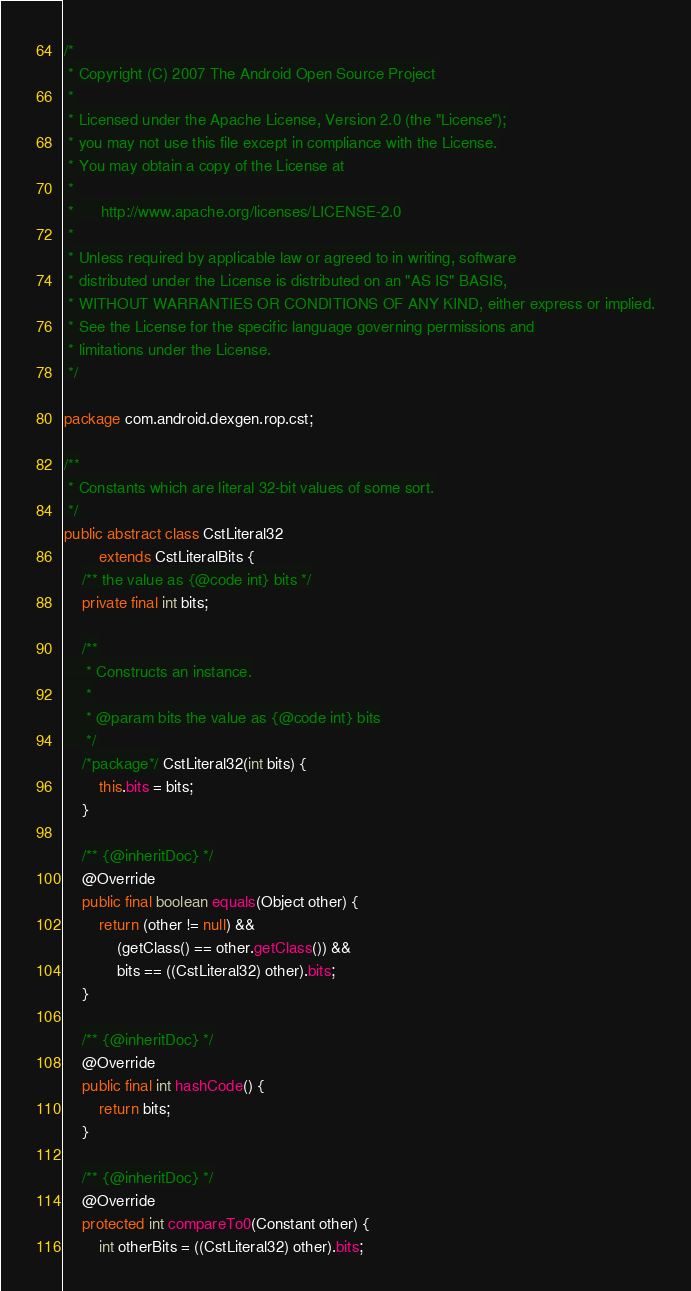Convert code to text. <code><loc_0><loc_0><loc_500><loc_500><_Java_>/*
 * Copyright (C) 2007 The Android Open Source Project
 *
 * Licensed under the Apache License, Version 2.0 (the "License");
 * you may not use this file except in compliance with the License.
 * You may obtain a copy of the License at
 *
 *      http://www.apache.org/licenses/LICENSE-2.0
 *
 * Unless required by applicable law or agreed to in writing, software
 * distributed under the License is distributed on an "AS IS" BASIS,
 * WITHOUT WARRANTIES OR CONDITIONS OF ANY KIND, either express or implied.
 * See the License for the specific language governing permissions and
 * limitations under the License.
 */

package com.android.dexgen.rop.cst;

/**
 * Constants which are literal 32-bit values of some sort.
 */
public abstract class CstLiteral32
        extends CstLiteralBits {
    /** the value as {@code int} bits */
    private final int bits;

    /**
     * Constructs an instance.
     *
     * @param bits the value as {@code int} bits
     */
    /*package*/ CstLiteral32(int bits) {
        this.bits = bits;
    }

    /** {@inheritDoc} */
    @Override
    public final boolean equals(Object other) {
        return (other != null) &&
            (getClass() == other.getClass()) &&
            bits == ((CstLiteral32) other).bits;
    }

    /** {@inheritDoc} */
    @Override
    public final int hashCode() {
        return bits;
    }

    /** {@inheritDoc} */
    @Override
    protected int compareTo0(Constant other) {
        int otherBits = ((CstLiteral32) other).bits;
</code> 